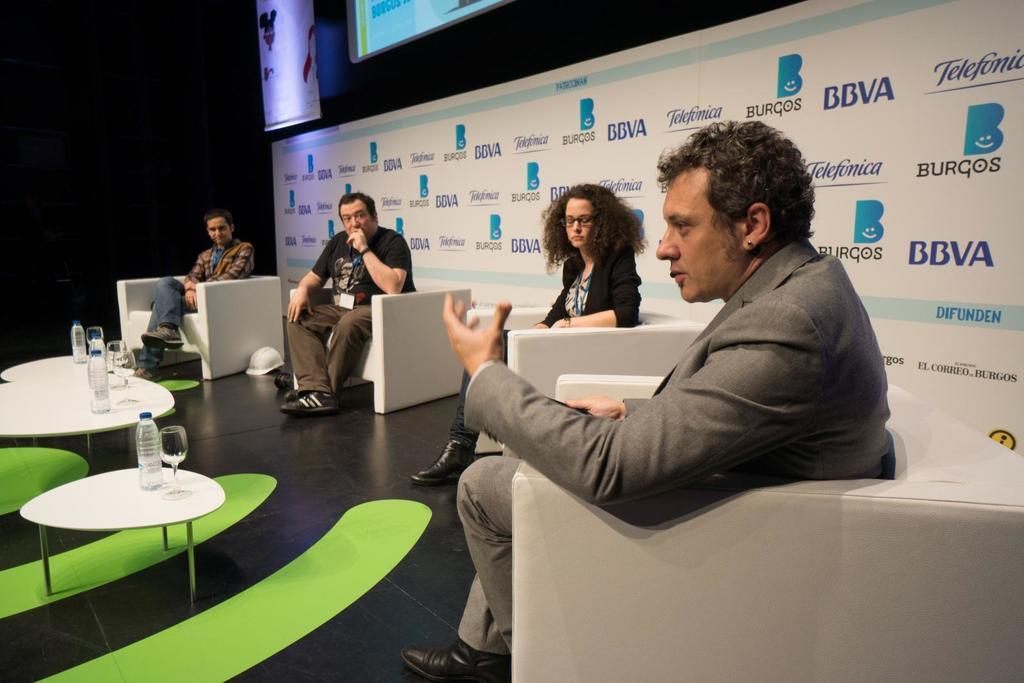Could you give a brief overview of what you see in this image? As we can see in the image there is screen, banner, few people sitting on sofas and there are tables. On tables there are glasses and bottles. 